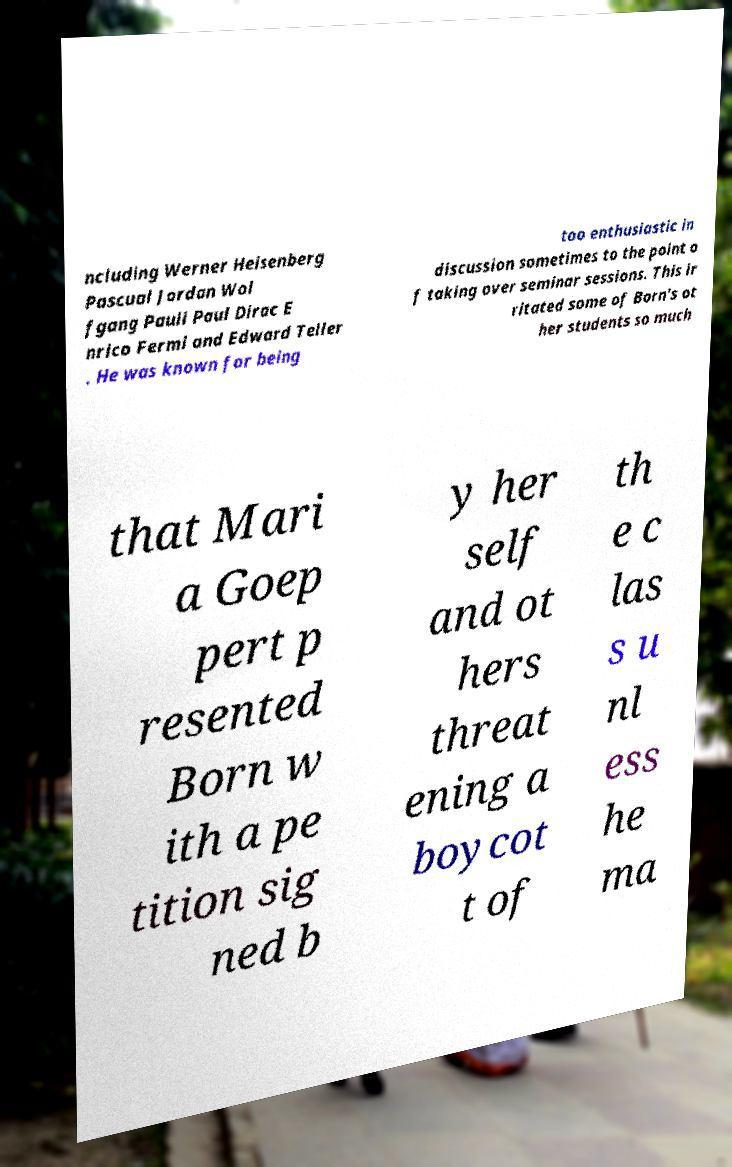Please read and relay the text visible in this image. What does it say? ncluding Werner Heisenberg Pascual Jordan Wol fgang Pauli Paul Dirac E nrico Fermi and Edward Teller . He was known for being too enthusiastic in discussion sometimes to the point o f taking over seminar sessions. This ir ritated some of Born's ot her students so much that Mari a Goep pert p resented Born w ith a pe tition sig ned b y her self and ot hers threat ening a boycot t of th e c las s u nl ess he ma 